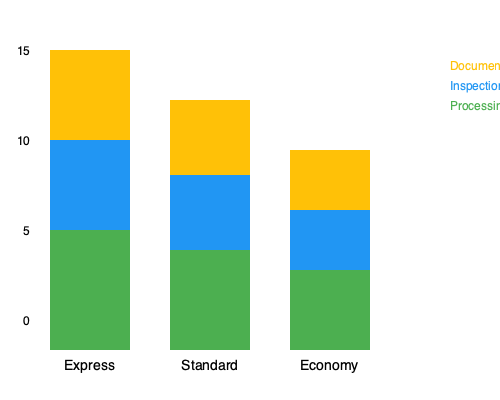Based on the stacked bar chart comparing customs clearance procedures for different shipping methods, which method has the longest total processing time, and what is the difference in documentation time between the fastest and slowest methods? To answer this question, we need to analyze the stacked bar chart and follow these steps:

1. Identify the total processing time for each shipping method:
   - Express: 15 days (3 + 6 + 6)
   - Standard: 12.5 days (2.5 + 5 + 5)
   - Economy: 10 days (2 + 4 + 4)

2. Determine the method with the longest total processing time:
   Express has the longest total processing time at 15 days.

3. Identify the documentation time for each method:
   - Express: 3 days
   - Standard: 2.5 days
   - Economy: 2 days

4. Calculate the difference in documentation time between the fastest and slowest methods:
   Slowest (Express) - Fastest (Economy) = 3 - 2 = 1 day

Therefore, Express shipping has the longest total processing time, and the difference in documentation time between the fastest (Economy) and slowest (Express) methods is 1 day.
Answer: Express; 1 day 